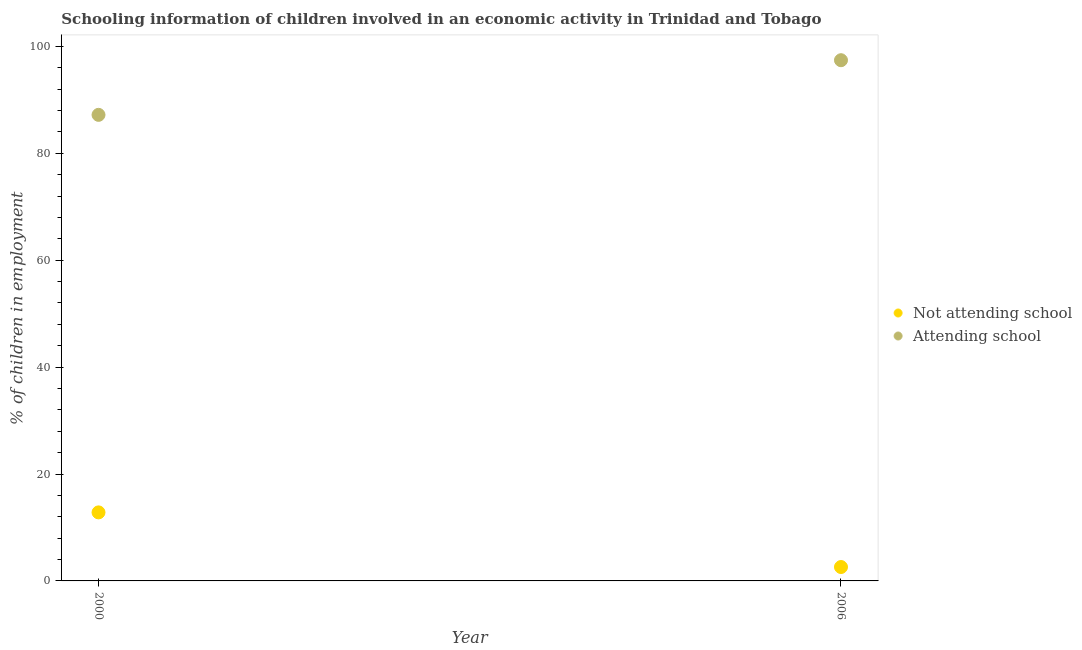What is the percentage of employed children who are attending school in 2000?
Offer a terse response. 87.18. Across all years, what is the maximum percentage of employed children who are not attending school?
Provide a short and direct response. 12.82. Across all years, what is the minimum percentage of employed children who are not attending school?
Keep it short and to the point. 2.6. What is the total percentage of employed children who are not attending school in the graph?
Offer a terse response. 15.42. What is the difference between the percentage of employed children who are attending school in 2000 and that in 2006?
Provide a short and direct response. -10.22. What is the difference between the percentage of employed children who are not attending school in 2006 and the percentage of employed children who are attending school in 2000?
Your answer should be very brief. -84.58. What is the average percentage of employed children who are not attending school per year?
Provide a succinct answer. 7.71. In the year 2006, what is the difference between the percentage of employed children who are attending school and percentage of employed children who are not attending school?
Ensure brevity in your answer.  94.8. In how many years, is the percentage of employed children who are attending school greater than 52 %?
Provide a succinct answer. 2. What is the ratio of the percentage of employed children who are not attending school in 2000 to that in 2006?
Ensure brevity in your answer.  4.93. Is the percentage of employed children who are attending school in 2000 less than that in 2006?
Provide a succinct answer. Yes. In how many years, is the percentage of employed children who are attending school greater than the average percentage of employed children who are attending school taken over all years?
Offer a terse response. 1. Does the percentage of employed children who are attending school monotonically increase over the years?
Your answer should be very brief. Yes. Is the percentage of employed children who are attending school strictly less than the percentage of employed children who are not attending school over the years?
Your response must be concise. No. Are the values on the major ticks of Y-axis written in scientific E-notation?
Make the answer very short. No. Does the graph contain any zero values?
Make the answer very short. No. How are the legend labels stacked?
Your answer should be compact. Vertical. What is the title of the graph?
Your answer should be compact. Schooling information of children involved in an economic activity in Trinidad and Tobago. Does "Methane emissions" appear as one of the legend labels in the graph?
Make the answer very short. No. What is the label or title of the X-axis?
Make the answer very short. Year. What is the label or title of the Y-axis?
Provide a succinct answer. % of children in employment. What is the % of children in employment in Not attending school in 2000?
Ensure brevity in your answer.  12.82. What is the % of children in employment in Attending school in 2000?
Keep it short and to the point. 87.18. What is the % of children in employment in Not attending school in 2006?
Your response must be concise. 2.6. What is the % of children in employment of Attending school in 2006?
Ensure brevity in your answer.  97.4. Across all years, what is the maximum % of children in employment in Not attending school?
Give a very brief answer. 12.82. Across all years, what is the maximum % of children in employment in Attending school?
Make the answer very short. 97.4. Across all years, what is the minimum % of children in employment in Not attending school?
Your answer should be very brief. 2.6. Across all years, what is the minimum % of children in employment of Attending school?
Keep it short and to the point. 87.18. What is the total % of children in employment of Not attending school in the graph?
Your answer should be very brief. 15.42. What is the total % of children in employment of Attending school in the graph?
Your answer should be very brief. 184.58. What is the difference between the % of children in employment in Not attending school in 2000 and that in 2006?
Make the answer very short. 10.22. What is the difference between the % of children in employment of Attending school in 2000 and that in 2006?
Offer a terse response. -10.22. What is the difference between the % of children in employment of Not attending school in 2000 and the % of children in employment of Attending school in 2006?
Offer a terse response. -84.58. What is the average % of children in employment of Not attending school per year?
Offer a very short reply. 7.71. What is the average % of children in employment in Attending school per year?
Offer a very short reply. 92.29. In the year 2000, what is the difference between the % of children in employment in Not attending school and % of children in employment in Attending school?
Your response must be concise. -74.36. In the year 2006, what is the difference between the % of children in employment of Not attending school and % of children in employment of Attending school?
Make the answer very short. -94.8. What is the ratio of the % of children in employment in Not attending school in 2000 to that in 2006?
Give a very brief answer. 4.93. What is the ratio of the % of children in employment in Attending school in 2000 to that in 2006?
Offer a terse response. 0.9. What is the difference between the highest and the second highest % of children in employment of Not attending school?
Your answer should be compact. 10.22. What is the difference between the highest and the second highest % of children in employment in Attending school?
Ensure brevity in your answer.  10.22. What is the difference between the highest and the lowest % of children in employment of Not attending school?
Provide a short and direct response. 10.22. What is the difference between the highest and the lowest % of children in employment in Attending school?
Offer a very short reply. 10.22. 